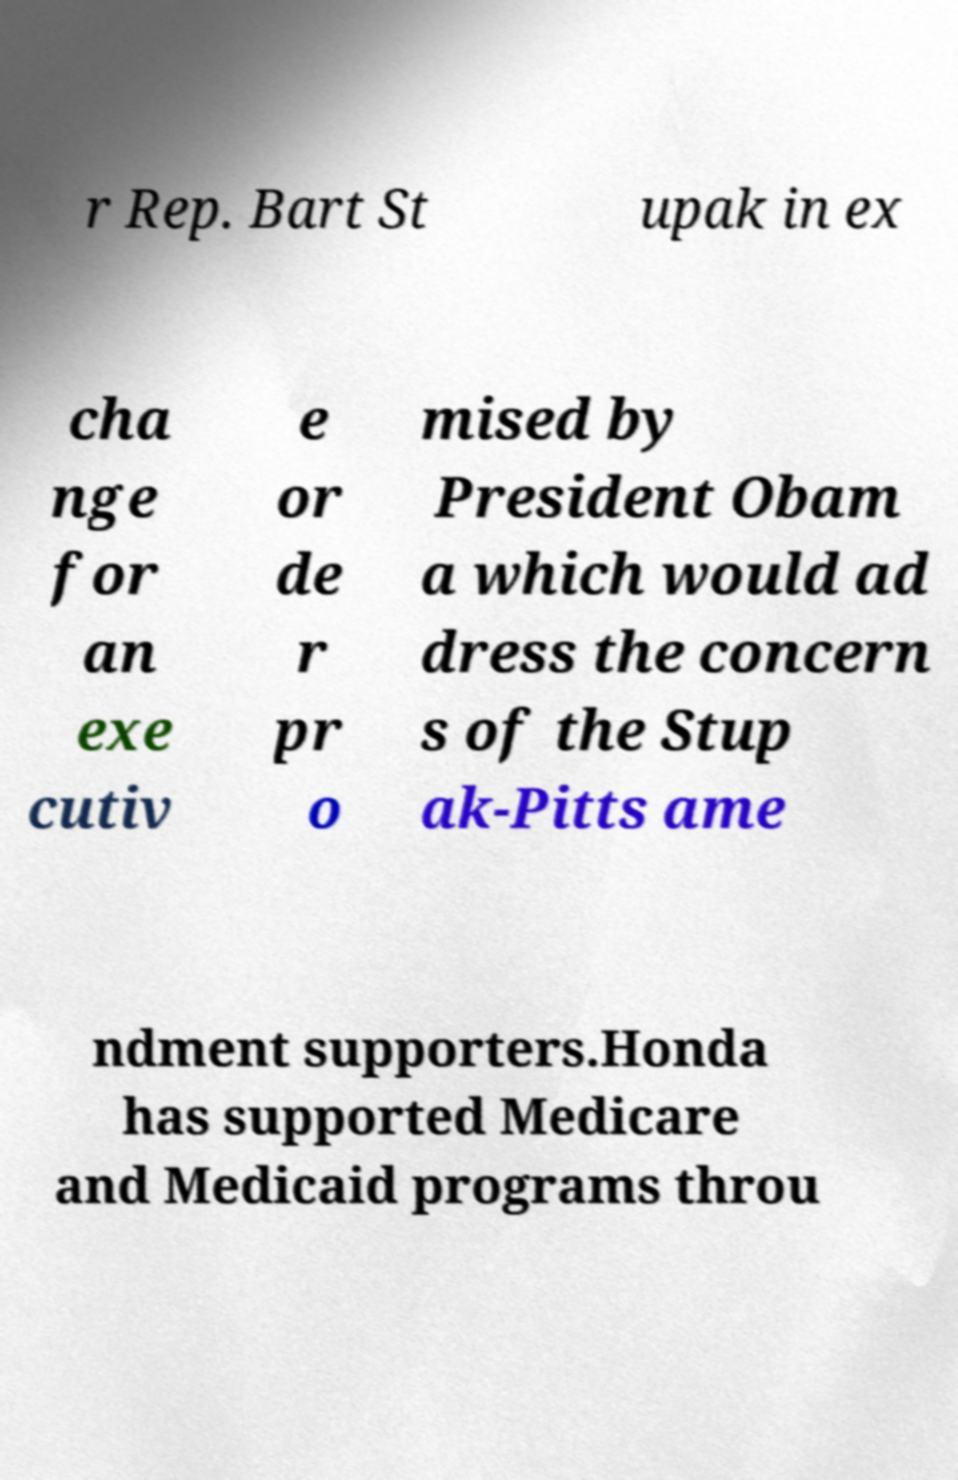There's text embedded in this image that I need extracted. Can you transcribe it verbatim? r Rep. Bart St upak in ex cha nge for an exe cutiv e or de r pr o mised by President Obam a which would ad dress the concern s of the Stup ak-Pitts ame ndment supporters.Honda has supported Medicare and Medicaid programs throu 